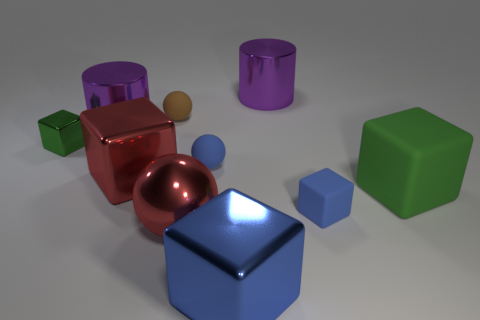Subtract all brown rubber spheres. How many spheres are left? 2 Subtract all red blocks. How many blocks are left? 4 Subtract 1 brown balls. How many objects are left? 9 Subtract all cylinders. How many objects are left? 8 Subtract 3 spheres. How many spheres are left? 0 Subtract all green cubes. Subtract all yellow cylinders. How many cubes are left? 3 Subtract all purple cylinders. How many brown blocks are left? 0 Subtract all red spheres. Subtract all small brown things. How many objects are left? 8 Add 2 blue matte objects. How many blue matte objects are left? 4 Add 5 tiny green metallic cubes. How many tiny green metallic cubes exist? 6 